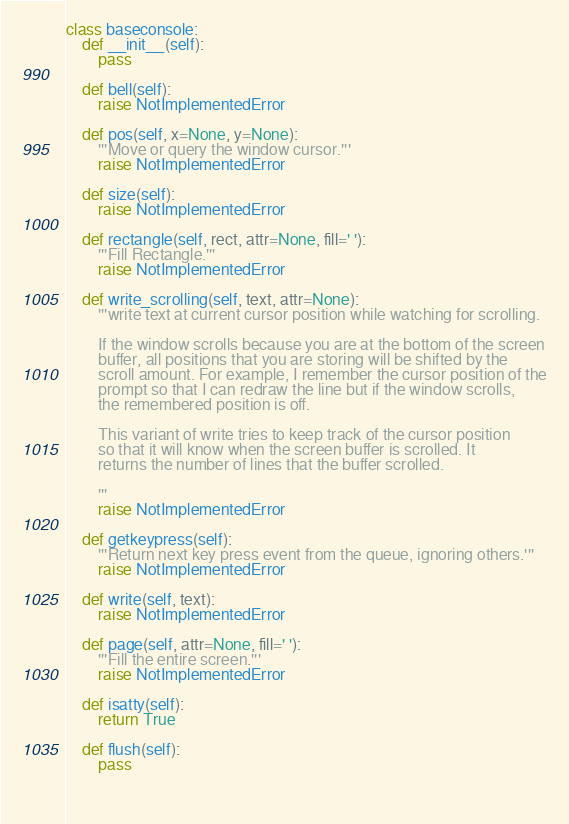Convert code to text. <code><loc_0><loc_0><loc_500><loc_500><_Python_>class baseconsole:
    def __init__(self):
        pass
        
    def bell(self):
        raise NotImplementedError

    def pos(self, x=None, y=None):
        '''Move or query the window cursor.'''
        raise NotImplementedError

    def size(self):
        raise NotImplementedError

    def rectangle(self, rect, attr=None, fill=' '):
        '''Fill Rectangle.'''
        raise NotImplementedError

    def write_scrolling(self, text, attr=None):
        '''write text at current cursor position while watching for scrolling.

        If the window scrolls because you are at the bottom of the screen
        buffer, all positions that you are storing will be shifted by the
        scroll amount. For example, I remember the cursor position of the
        prompt so that I can redraw the line but if the window scrolls,
        the remembered position is off.

        This variant of write tries to keep track of the cursor position
        so that it will know when the screen buffer is scrolled. It
        returns the number of lines that the buffer scrolled.

        '''
        raise NotImplementedError
    
    def getkeypress(self):
        '''Return next key press event from the queue, ignoring others.'''
        raise NotImplementedError
        
    def write(self, text):
        raise NotImplementedError
    
    def page(self, attr=None, fill=' '):
        '''Fill the entire screen.'''
        raise NotImplementedError

    def isatty(self):
        return True

    def flush(self):
        pass

    </code> 